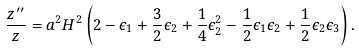Convert formula to latex. <formula><loc_0><loc_0><loc_500><loc_500>\frac { z ^ { \prime \prime } } z = a ^ { 2 } H ^ { 2 } \left ( 2 - \epsilon _ { 1 } + \frac { 3 } { 2 } \epsilon _ { 2 } + \frac { 1 } { 4 } \epsilon _ { 2 } ^ { 2 } - \frac { 1 } { 2 } \epsilon _ { 1 } \epsilon _ { 2 } + \frac { 1 } { 2 } \epsilon _ { 2 } \epsilon _ { 3 } \right ) .</formula> 